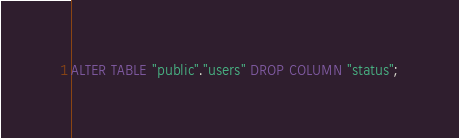Convert code to text. <code><loc_0><loc_0><loc_500><loc_500><_SQL_>ALTER TABLE "public"."users" DROP COLUMN "status";
</code> 